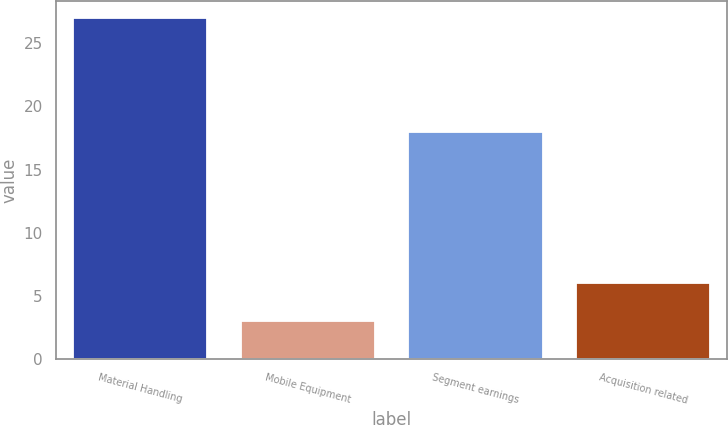Convert chart to OTSL. <chart><loc_0><loc_0><loc_500><loc_500><bar_chart><fcel>Material Handling<fcel>Mobile Equipment<fcel>Segment earnings<fcel>Acquisition related<nl><fcel>27<fcel>3<fcel>18<fcel>6<nl></chart> 